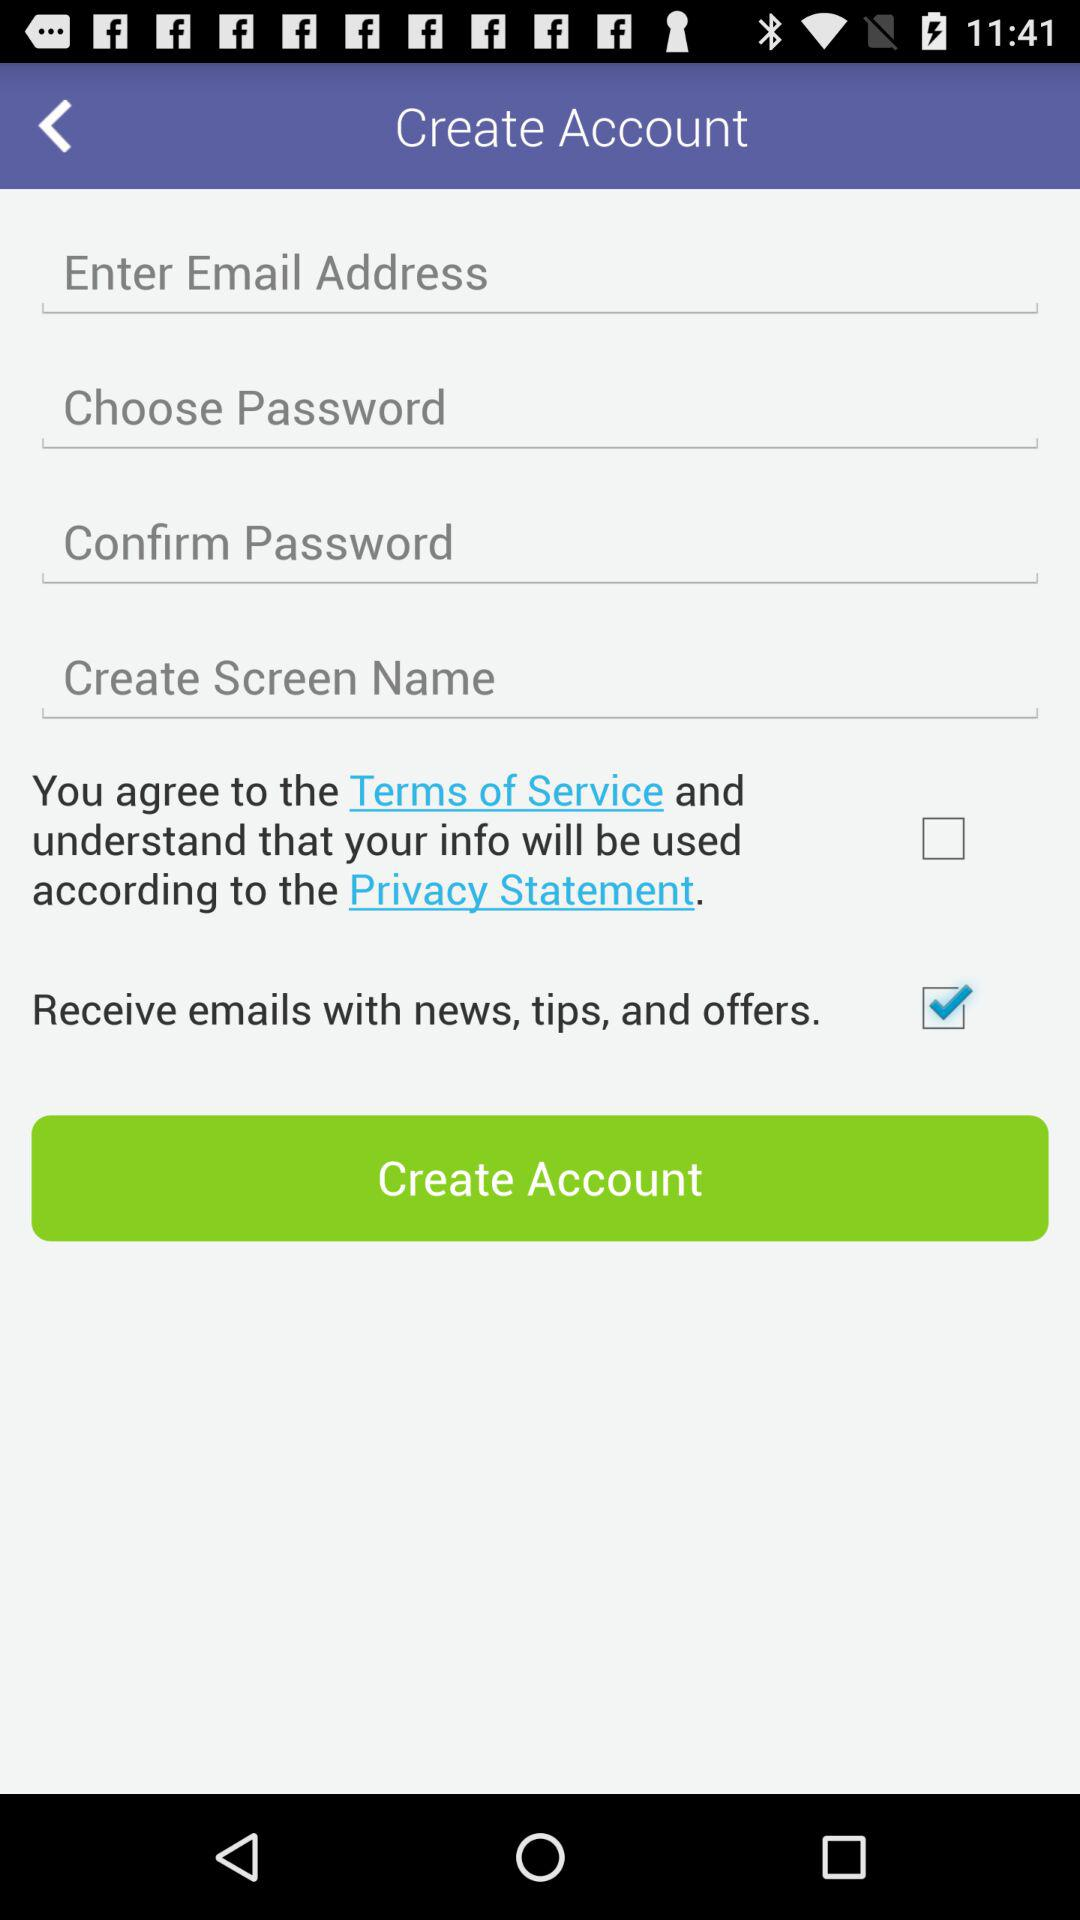Has the user agreed to the terms of service and privacy statement?
When the provided information is insufficient, respond with <no answer>. <no answer> 